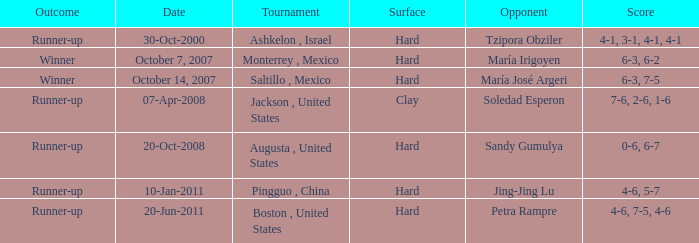What was the conclusion when jing-jing lu was the competitor? Runner-up. 